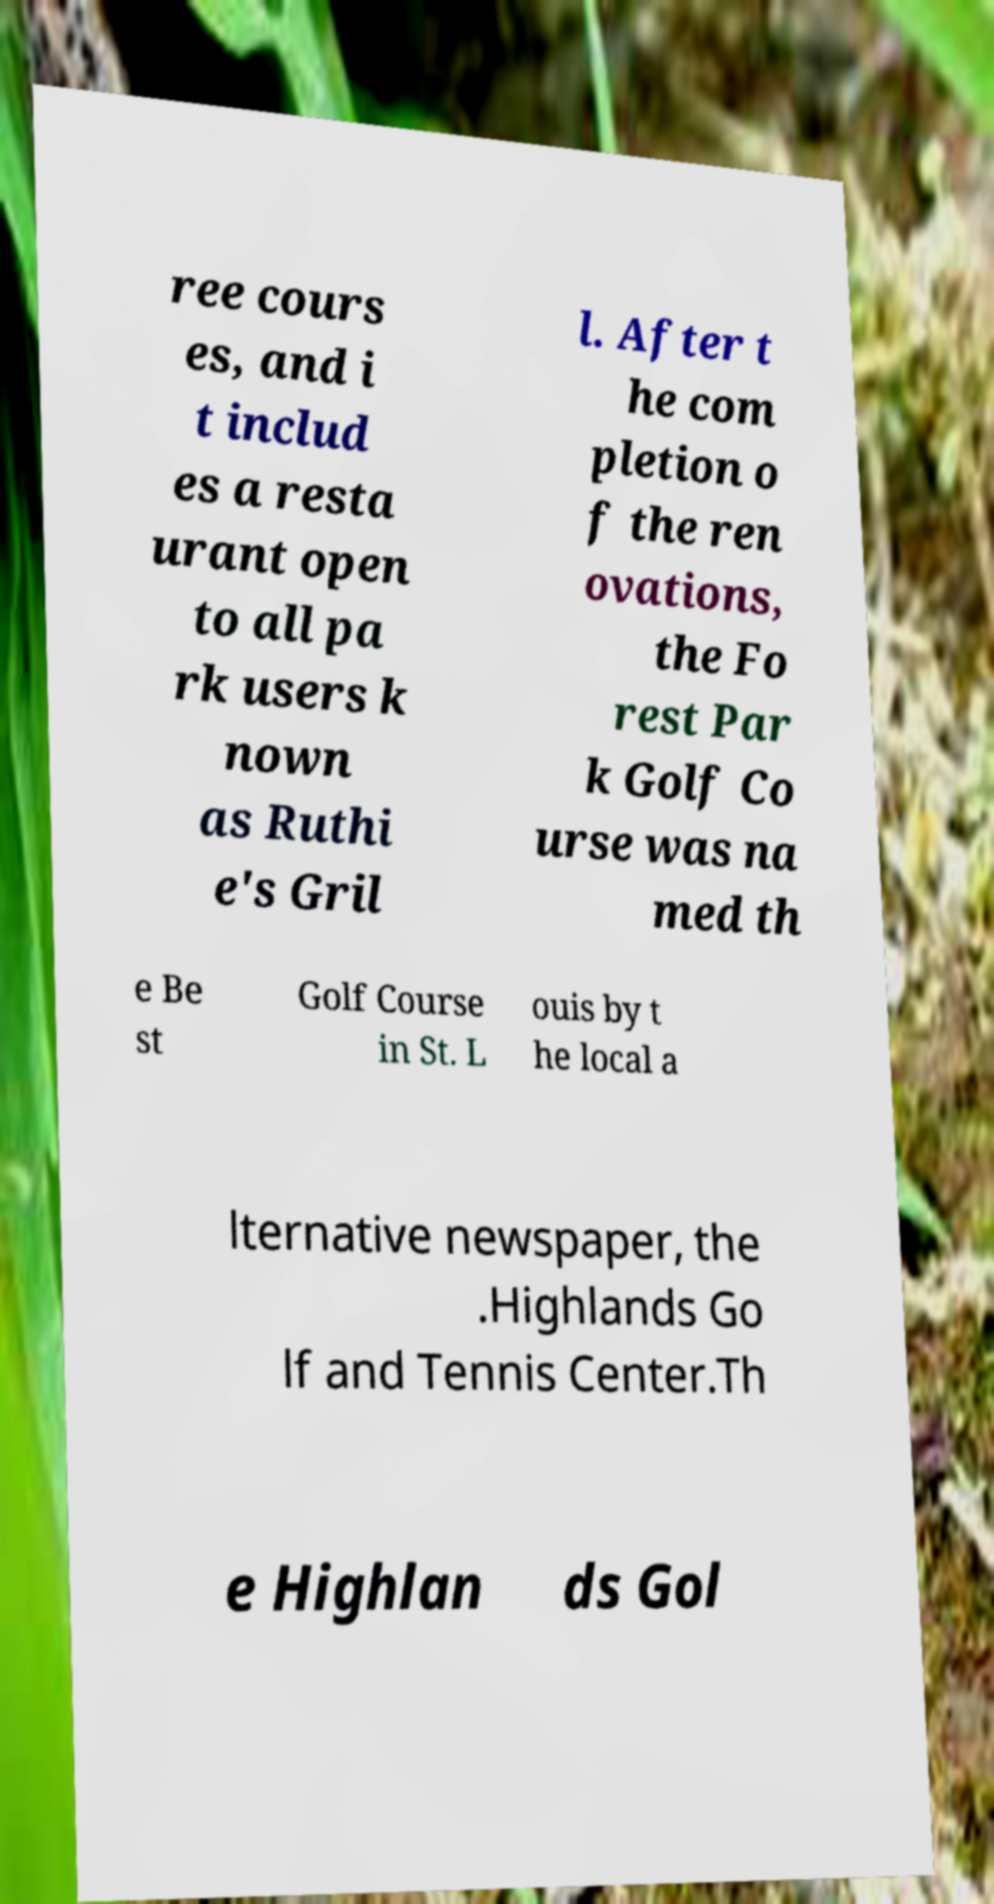Can you accurately transcribe the text from the provided image for me? ree cours es, and i t includ es a resta urant open to all pa rk users k nown as Ruthi e's Gril l. After t he com pletion o f the ren ovations, the Fo rest Par k Golf Co urse was na med th e Be st Golf Course in St. L ouis by t he local a lternative newspaper, the .Highlands Go lf and Tennis Center.Th e Highlan ds Gol 